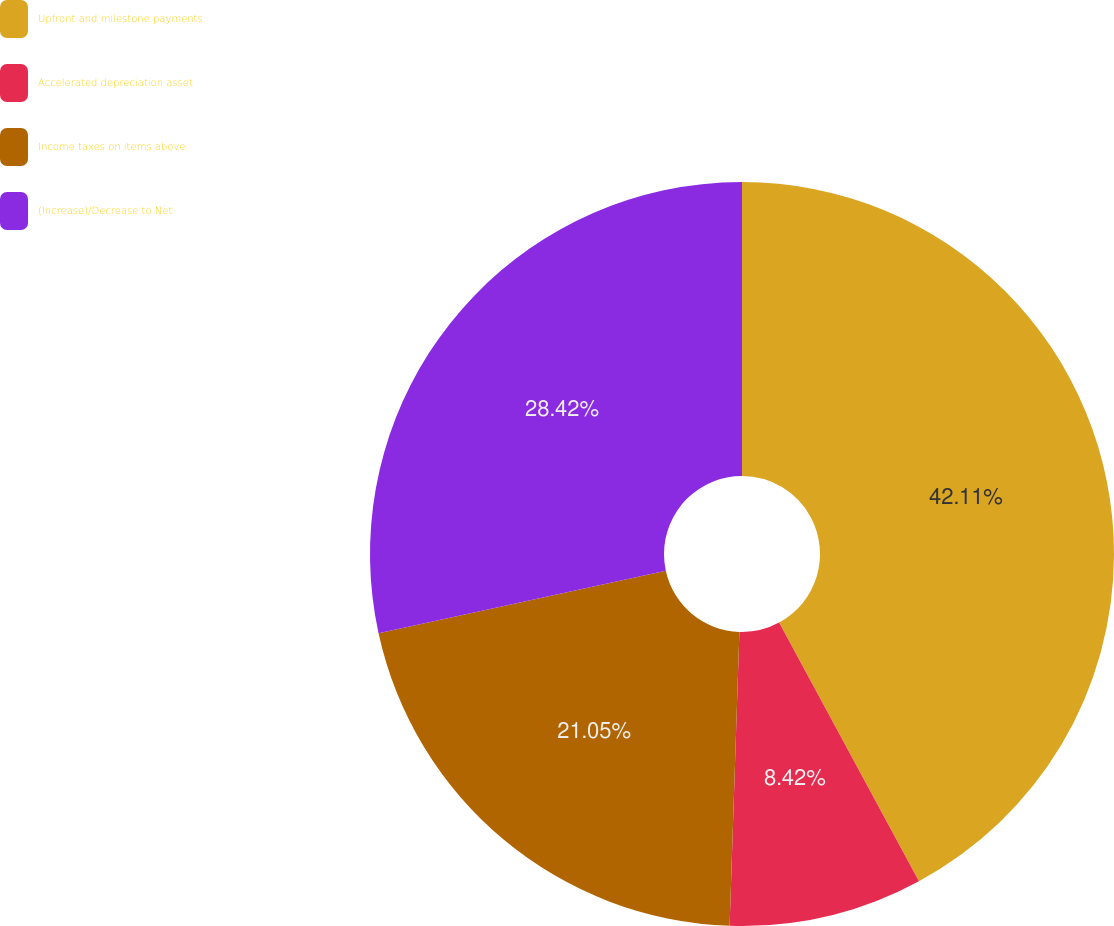Convert chart. <chart><loc_0><loc_0><loc_500><loc_500><pie_chart><fcel>Upfront and milestone payments<fcel>Accelerated depreciation asset<fcel>Income taxes on items above<fcel>(Increase)/Decrease to Net<nl><fcel>42.11%<fcel>8.42%<fcel>21.05%<fcel>28.42%<nl></chart> 